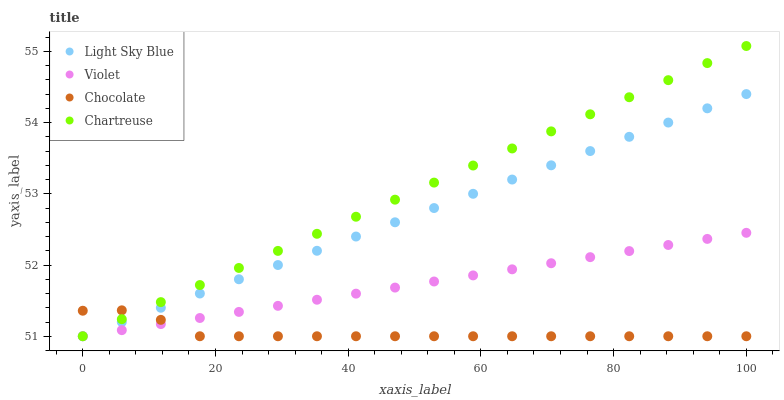Does Chocolate have the minimum area under the curve?
Answer yes or no. Yes. Does Chartreuse have the maximum area under the curve?
Answer yes or no. Yes. Does Light Sky Blue have the minimum area under the curve?
Answer yes or no. No. Does Light Sky Blue have the maximum area under the curve?
Answer yes or no. No. Is Violet the smoothest?
Answer yes or no. Yes. Is Chocolate the roughest?
Answer yes or no. Yes. Is Chartreuse the smoothest?
Answer yes or no. No. Is Chartreuse the roughest?
Answer yes or no. No. Does Chocolate have the lowest value?
Answer yes or no. Yes. Does Chartreuse have the highest value?
Answer yes or no. Yes. Does Light Sky Blue have the highest value?
Answer yes or no. No. Does Chocolate intersect Light Sky Blue?
Answer yes or no. Yes. Is Chocolate less than Light Sky Blue?
Answer yes or no. No. Is Chocolate greater than Light Sky Blue?
Answer yes or no. No. 